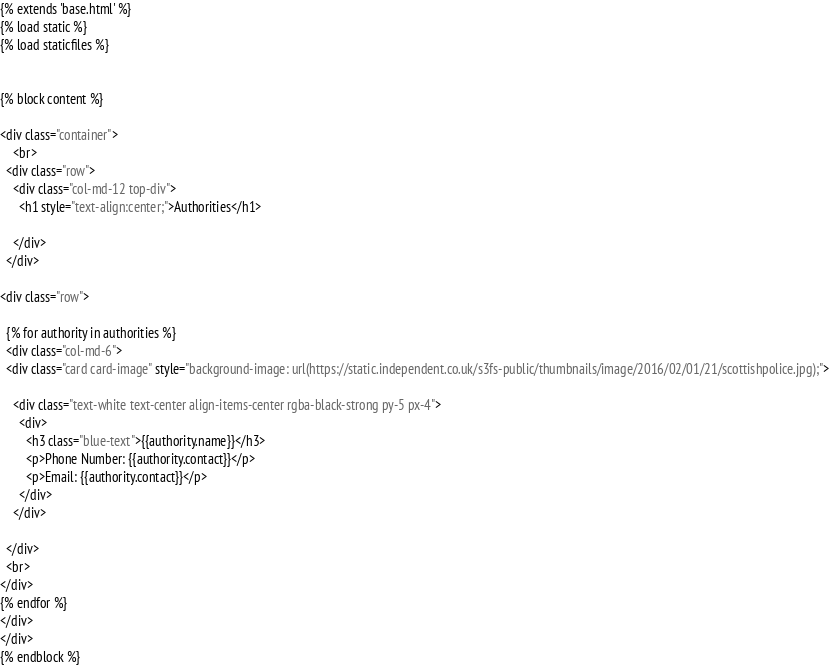Convert code to text. <code><loc_0><loc_0><loc_500><loc_500><_HTML_>{% extends 'base.html' %}
{% load static %}
{% load staticfiles %}


{% block content %}

<div class="container">
    <br>
  <div class="row">
    <div class="col-md-12 top-div">
      <h1 style="text-align:center;">Authorities</h1>

    </div>
  </div>

<div class="row">

  {% for authority in authorities %}
  <div class="col-md-6">
  <div class="card card-image" style="background-image: url(https://static.independent.co.uk/s3fs-public/thumbnails/image/2016/02/01/21/scottishpolice.jpg);">

    <div class="text-white text-center align-items-center rgba-black-strong py-5 px-4">
      <div>
        <h3 class="blue-text">{{authority.name}}</h3>
        <p>Phone Number: {{authority.contact}}</p>
        <p>Email: {{authority.contact}}</p>
      </div>
    </div>

  </div>
  <br>
</div>
{% endfor %}
</div>
</div>
{% endblock %}</code> 